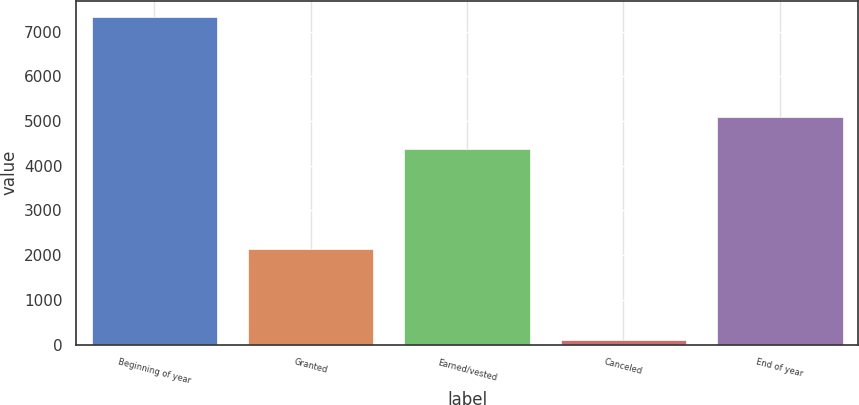Convert chart. <chart><loc_0><loc_0><loc_500><loc_500><bar_chart><fcel>Beginning of year<fcel>Granted<fcel>Earned/vested<fcel>Canceled<fcel>End of year<nl><fcel>7328<fcel>2134<fcel>4372<fcel>91<fcel>5095.7<nl></chart> 